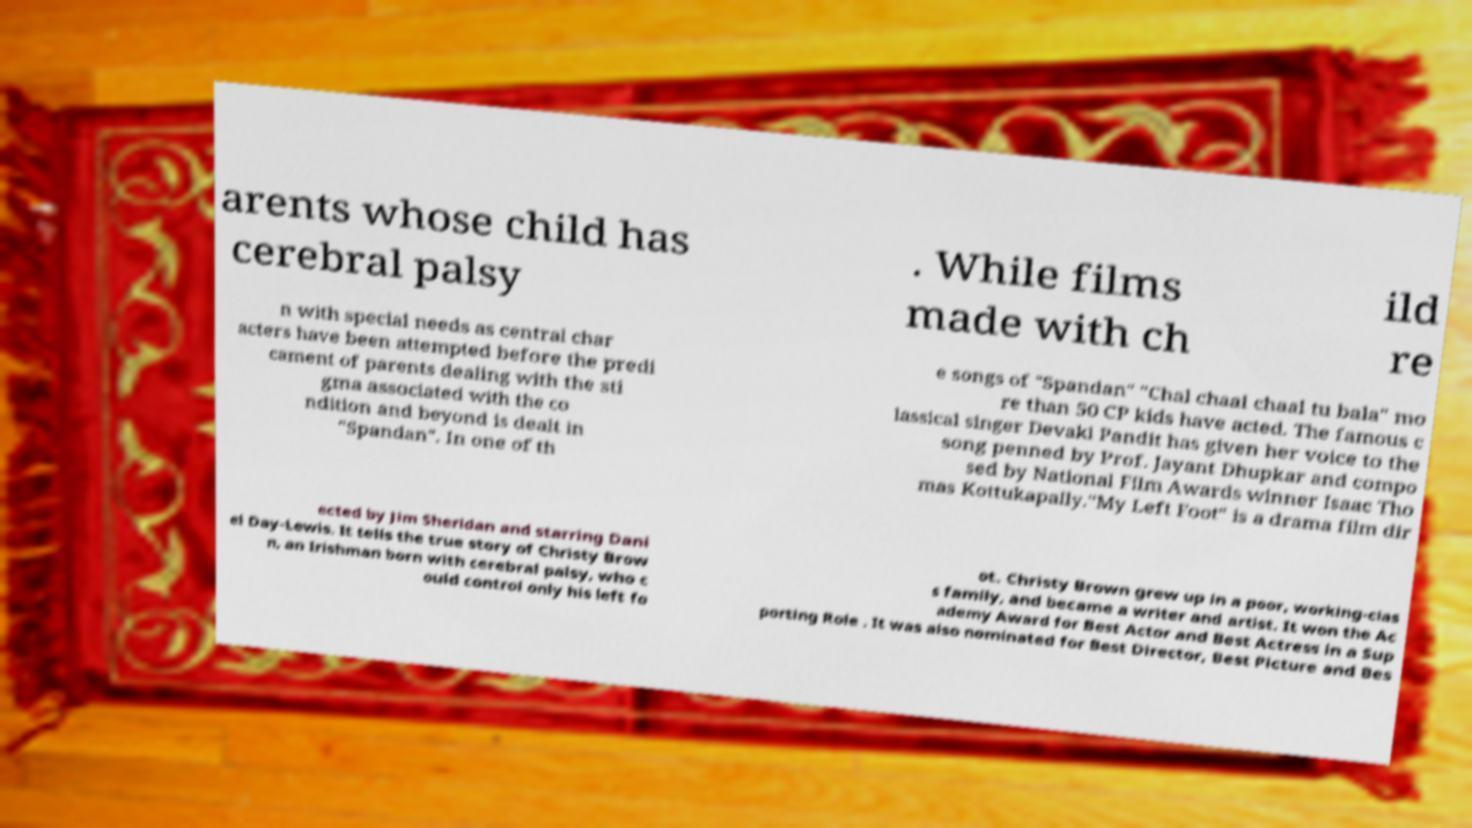What messages or text are displayed in this image? I need them in a readable, typed format. arents whose child has cerebral palsy . While films made with ch ild re n with special needs as central char acters have been attempted before the predi cament of parents dealing with the sti gma associated with the co ndition and beyond is dealt in "Spandan". In one of th e songs of "Spandan" "Chal chaal chaal tu bala" mo re than 50 CP kids have acted. The famous c lassical singer Devaki Pandit has given her voice to the song penned by Prof. Jayant Dhupkar and compo sed by National Film Awards winner Isaac Tho mas Kottukapally."My Left Foot" is a drama film dir ected by Jim Sheridan and starring Dani el Day-Lewis. It tells the true story of Christy Brow n, an Irishman born with cerebral palsy, who c ould control only his left fo ot. Christy Brown grew up in a poor, working-clas s family, and became a writer and artist. It won the Ac ademy Award for Best Actor and Best Actress in a Sup porting Role . It was also nominated for Best Director, Best Picture and Bes 